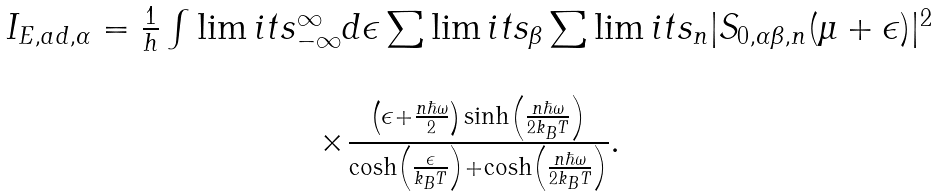Convert formula to latex. <formula><loc_0><loc_0><loc_500><loc_500>\begin{array} { c } I _ { E , a d , \alpha } = \frac { 1 } { h } \int \lim i t s _ { - \infty } ^ { \infty } d \epsilon \sum \lim i t s _ { \beta } \sum \lim i t s _ { n } | S _ { 0 , \alpha \beta , n } ( \mu + \epsilon ) | ^ { 2 } \\ \ \\ \times \frac { \left ( \epsilon + \frac { n \hbar { \omega } } { 2 } \right ) \sinh \left ( \frac { n \hbar { \omega } } { 2 k _ { B } T } \right ) } { \cosh \left ( \frac { \epsilon } { k _ { B } T } \right ) + \cosh \left ( \frac { n \hbar { \omega } } { 2 k _ { B } T } \right ) } . \end{array}</formula> 